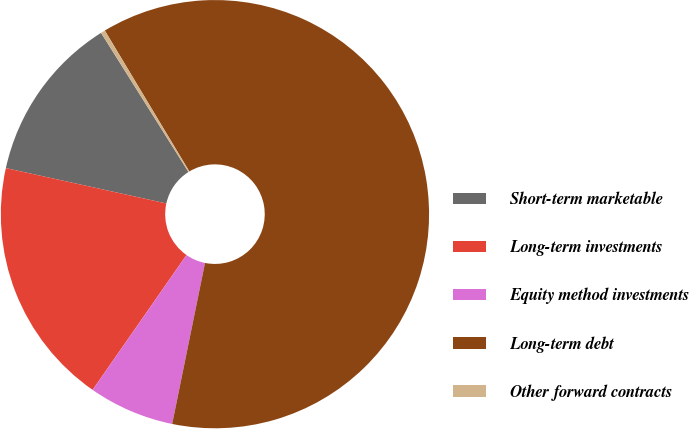<chart> <loc_0><loc_0><loc_500><loc_500><pie_chart><fcel>Short-term marketable<fcel>Long-term investments<fcel>Equity method investments<fcel>Long-term debt<fcel>Other forward contracts<nl><fcel>12.62%<fcel>18.77%<fcel>6.48%<fcel>61.8%<fcel>0.33%<nl></chart> 